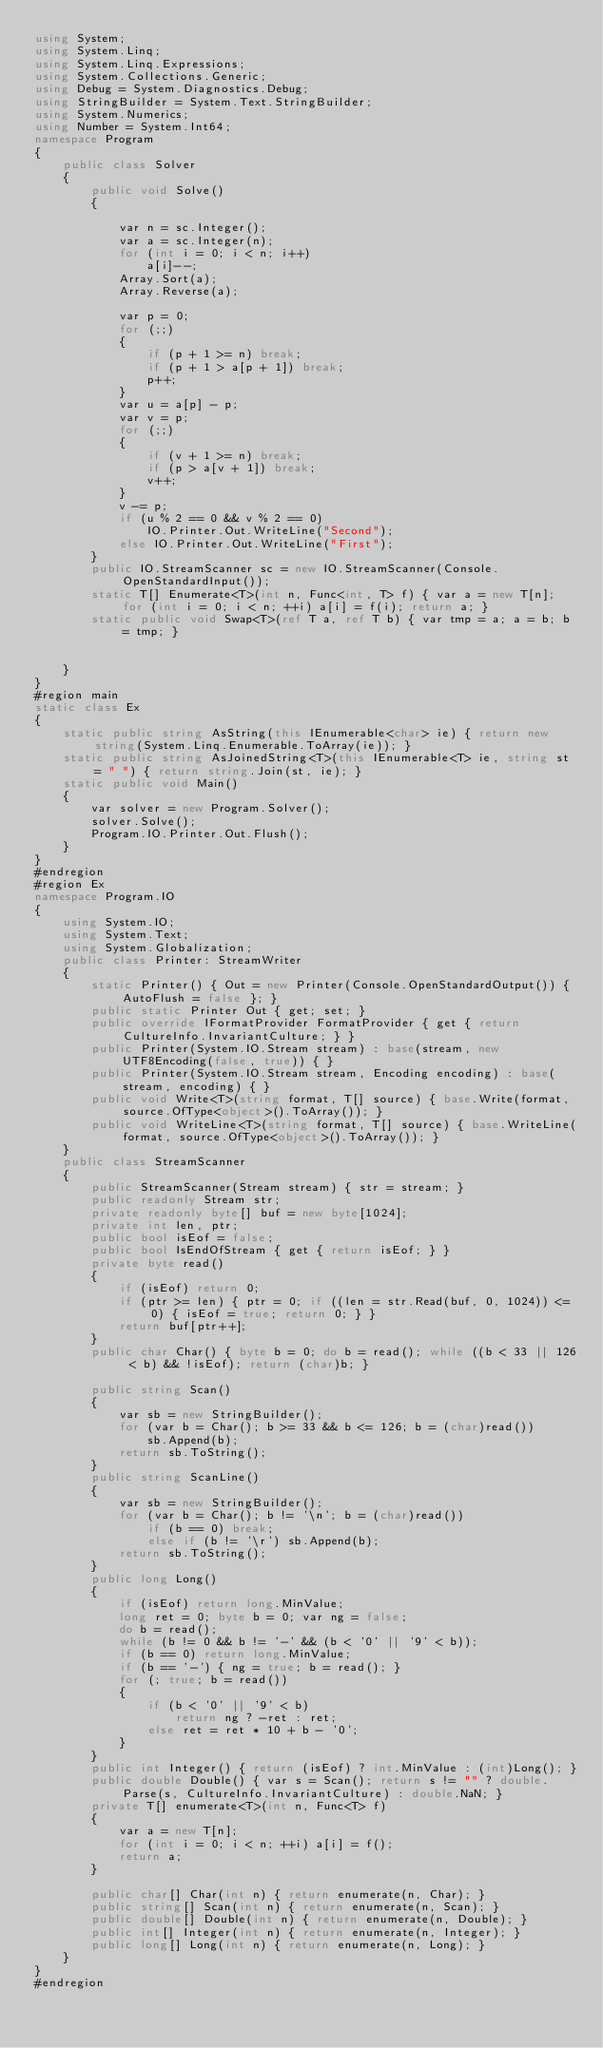Convert code to text. <code><loc_0><loc_0><loc_500><loc_500><_C#_>using System;
using System.Linq;
using System.Linq.Expressions;
using System.Collections.Generic;
using Debug = System.Diagnostics.Debug;
using StringBuilder = System.Text.StringBuilder;
using System.Numerics;
using Number = System.Int64;
namespace Program
{
    public class Solver
    {
        public void Solve()
        {

            var n = sc.Integer();
            var a = sc.Integer(n);
            for (int i = 0; i < n; i++)
                a[i]--;
            Array.Sort(a);
            Array.Reverse(a);

            var p = 0;
            for (;;)
            {
                if (p + 1 >= n) break;
                if (p + 1 > a[p + 1]) break;
                p++;
            }
            var u = a[p] - p;
            var v = p;
            for (;;)
            {
                if (v + 1 >= n) break;
                if (p > a[v + 1]) break;
                v++;
            }
            v -= p;
            if (u % 2 == 0 && v % 2 == 0)
                IO.Printer.Out.WriteLine("Second");
            else IO.Printer.Out.WriteLine("First");
        }
        public IO.StreamScanner sc = new IO.StreamScanner(Console.OpenStandardInput());
        static T[] Enumerate<T>(int n, Func<int, T> f) { var a = new T[n]; for (int i = 0; i < n; ++i) a[i] = f(i); return a; }
        static public void Swap<T>(ref T a, ref T b) { var tmp = a; a = b; b = tmp; }


    }
}
#region main
static class Ex
{
    static public string AsString(this IEnumerable<char> ie) { return new string(System.Linq.Enumerable.ToArray(ie)); }
    static public string AsJoinedString<T>(this IEnumerable<T> ie, string st = " ") { return string.Join(st, ie); }
    static public void Main()
    {
        var solver = new Program.Solver();
        solver.Solve();
        Program.IO.Printer.Out.Flush();
    }
}
#endregion
#region Ex
namespace Program.IO
{
    using System.IO;
    using System.Text;
    using System.Globalization;
    public class Printer: StreamWriter
    {
        static Printer() { Out = new Printer(Console.OpenStandardOutput()) { AutoFlush = false }; }
        public static Printer Out { get; set; }
        public override IFormatProvider FormatProvider { get { return CultureInfo.InvariantCulture; } }
        public Printer(System.IO.Stream stream) : base(stream, new UTF8Encoding(false, true)) { }
        public Printer(System.IO.Stream stream, Encoding encoding) : base(stream, encoding) { }
        public void Write<T>(string format, T[] source) { base.Write(format, source.OfType<object>().ToArray()); }
        public void WriteLine<T>(string format, T[] source) { base.WriteLine(format, source.OfType<object>().ToArray()); }
    }
    public class StreamScanner
    {
        public StreamScanner(Stream stream) { str = stream; }
        public readonly Stream str;
        private readonly byte[] buf = new byte[1024];
        private int len, ptr;
        public bool isEof = false;
        public bool IsEndOfStream { get { return isEof; } }
        private byte read()
        {
            if (isEof) return 0;
            if (ptr >= len) { ptr = 0; if ((len = str.Read(buf, 0, 1024)) <= 0) { isEof = true; return 0; } }
            return buf[ptr++];
        }
        public char Char() { byte b = 0; do b = read(); while ((b < 33 || 126 < b) && !isEof); return (char)b; }

        public string Scan()
        {
            var sb = new StringBuilder();
            for (var b = Char(); b >= 33 && b <= 126; b = (char)read())
                sb.Append(b);
            return sb.ToString();
        }
        public string ScanLine()
        {
            var sb = new StringBuilder();
            for (var b = Char(); b != '\n'; b = (char)read())
                if (b == 0) break;
                else if (b != '\r') sb.Append(b);
            return sb.ToString();
        }
        public long Long()
        {
            if (isEof) return long.MinValue;
            long ret = 0; byte b = 0; var ng = false;
            do b = read();
            while (b != 0 && b != '-' && (b < '0' || '9' < b));
            if (b == 0) return long.MinValue;
            if (b == '-') { ng = true; b = read(); }
            for (; true; b = read())
            {
                if (b < '0' || '9' < b)
                    return ng ? -ret : ret;
                else ret = ret * 10 + b - '0';
            }
        }
        public int Integer() { return (isEof) ? int.MinValue : (int)Long(); }
        public double Double() { var s = Scan(); return s != "" ? double.Parse(s, CultureInfo.InvariantCulture) : double.NaN; }
        private T[] enumerate<T>(int n, Func<T> f)
        {
            var a = new T[n];
            for (int i = 0; i < n; ++i) a[i] = f();
            return a;
        }

        public char[] Char(int n) { return enumerate(n, Char); }
        public string[] Scan(int n) { return enumerate(n, Scan); }
        public double[] Double(int n) { return enumerate(n, Double); }
        public int[] Integer(int n) { return enumerate(n, Integer); }
        public long[] Long(int n) { return enumerate(n, Long); }
    }
}
#endregion
</code> 